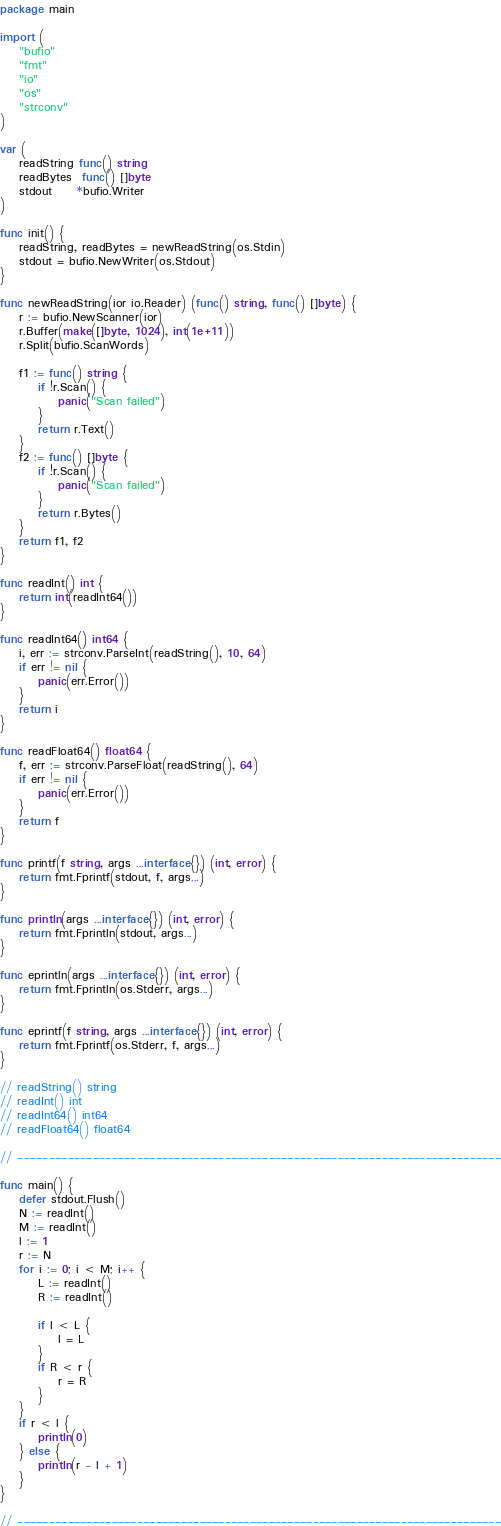Convert code to text. <code><loc_0><loc_0><loc_500><loc_500><_Go_>package main

import (
	"bufio"
	"fmt"
	"io"
	"os"
	"strconv"
)

var (
	readString func() string
	readBytes  func() []byte
	stdout     *bufio.Writer
)

func init() {
	readString, readBytes = newReadString(os.Stdin)
	stdout = bufio.NewWriter(os.Stdout)
}

func newReadString(ior io.Reader) (func() string, func() []byte) {
	r := bufio.NewScanner(ior)
	r.Buffer(make([]byte, 1024), int(1e+11))
	r.Split(bufio.ScanWords)

	f1 := func() string {
		if !r.Scan() {
			panic("Scan failed")
		}
		return r.Text()
	}
	f2 := func() []byte {
		if !r.Scan() {
			panic("Scan failed")
		}
		return r.Bytes()
	}
	return f1, f2
}

func readInt() int {
	return int(readInt64())
}

func readInt64() int64 {
	i, err := strconv.ParseInt(readString(), 10, 64)
	if err != nil {
		panic(err.Error())
	}
	return i
}

func readFloat64() float64 {
	f, err := strconv.ParseFloat(readString(), 64)
	if err != nil {
		panic(err.Error())
	}
	return f
}

func printf(f string, args ...interface{}) (int, error) {
	return fmt.Fprintf(stdout, f, args...)
}

func println(args ...interface{}) (int, error) {
	return fmt.Fprintln(stdout, args...)
}

func eprintln(args ...interface{}) (int, error) {
	return fmt.Fprintln(os.Stderr, args...)
}

func eprintf(f string, args ...interface{}) (int, error) {
	return fmt.Fprintf(os.Stderr, f, args...)
}

// readString() string
// readInt() int
// readInt64() int64
// readFloat64() float64

// -----------------------------------------------------------------------------

func main() {
	defer stdout.Flush()
	N := readInt()
	M := readInt()
	l := 1
	r := N
	for i := 0; i < M; i++ {
		L := readInt()
		R := readInt()

		if l < L {
			l = L
		}
		if R < r {
			r = R
		}
	}
	if r < l {
		println(0)
	} else {
		println(r - l + 1)
	}
}

// -----------------------------------------------------------------------------
</code> 